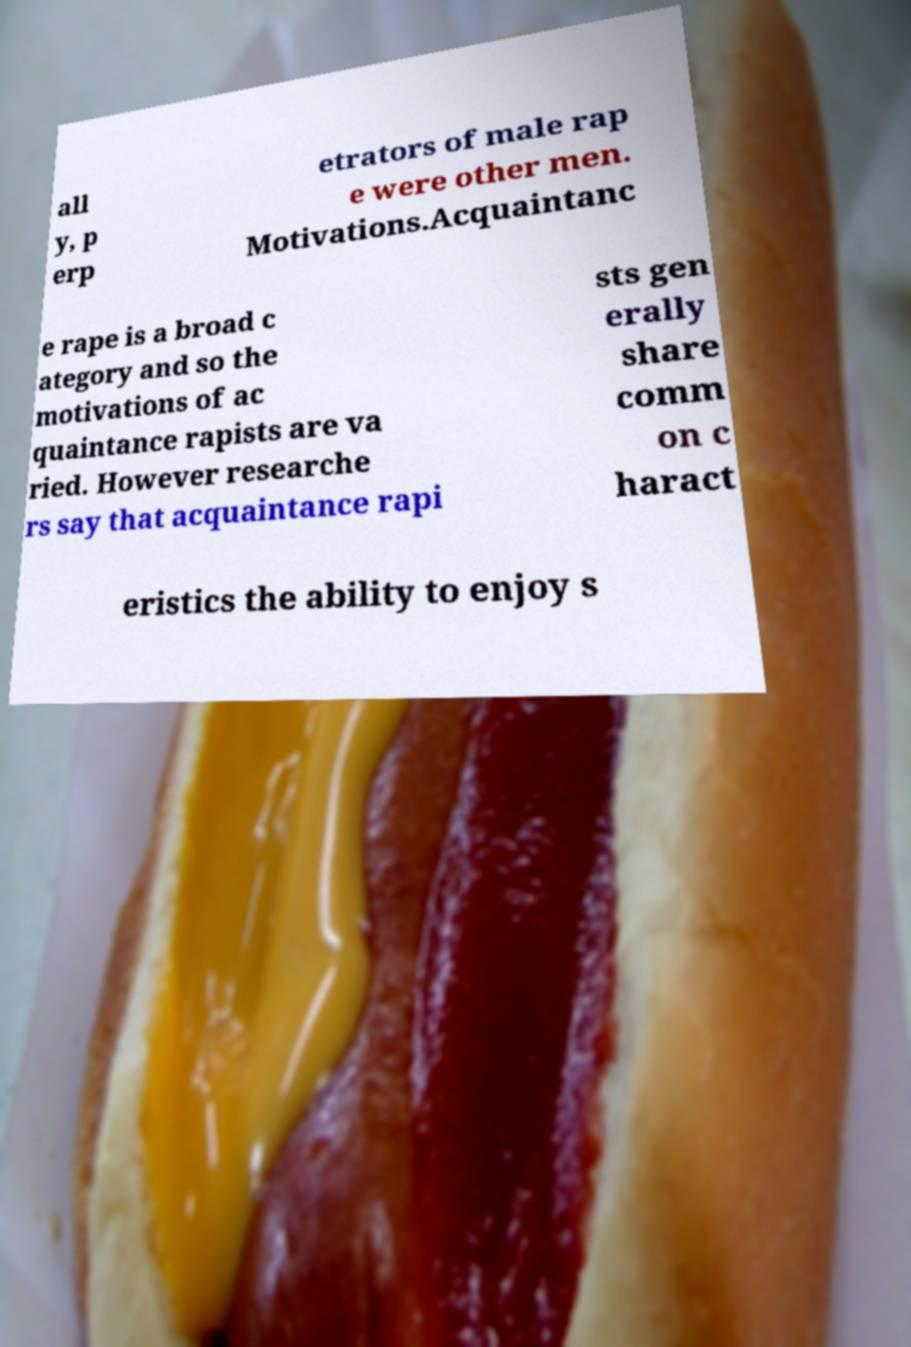Can you accurately transcribe the text from the provided image for me? all y, p erp etrators of male rap e were other men. Motivations.Acquaintanc e rape is a broad c ategory and so the motivations of ac quaintance rapists are va ried. However researche rs say that acquaintance rapi sts gen erally share comm on c haract eristics the ability to enjoy s 